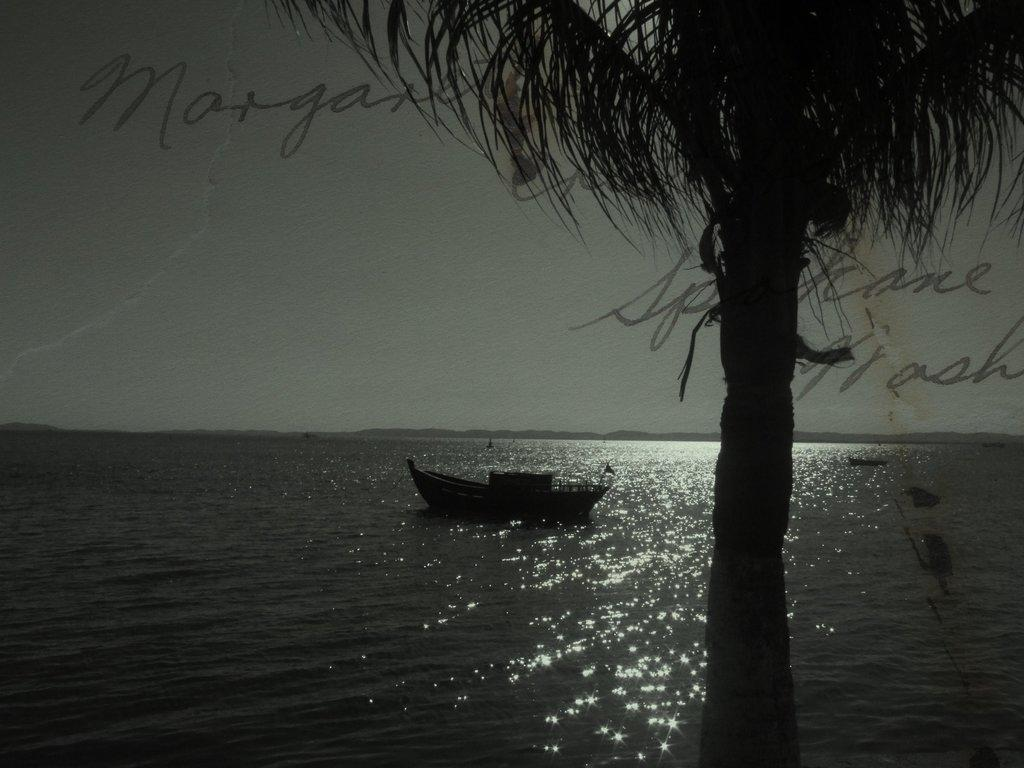What is the main subject of the image? The main subject of the image is a boat. Where is the boat located? The boat is on the ocean. What other natural features can be seen in the image? There is a tree and mountains visible in the image. What part of the environment is not visible in the image? The ground is not visible in the image. What is visible in the sky? The sky is visible in the image. Are there any words or letters in the image? Yes, there are text on the image. Can you tell me how many goldfish are swimming in the ocean in the image? There are no goldfish visible in the image; it features a boat on the ocean. What type of sign is present on the top of the boat in the image? There is no sign present on the top of the boat in the image. 